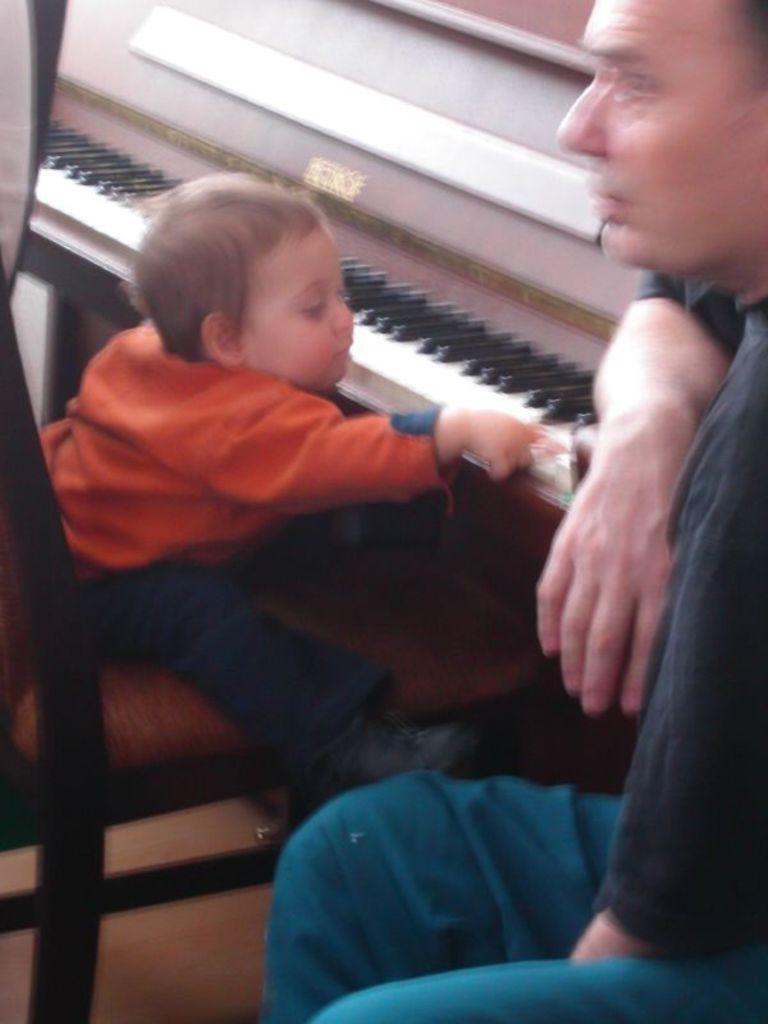In one or two sentences, can you explain what this image depicts? There is a kid sitting in a chair and playing with piano and there is a person beside him. 